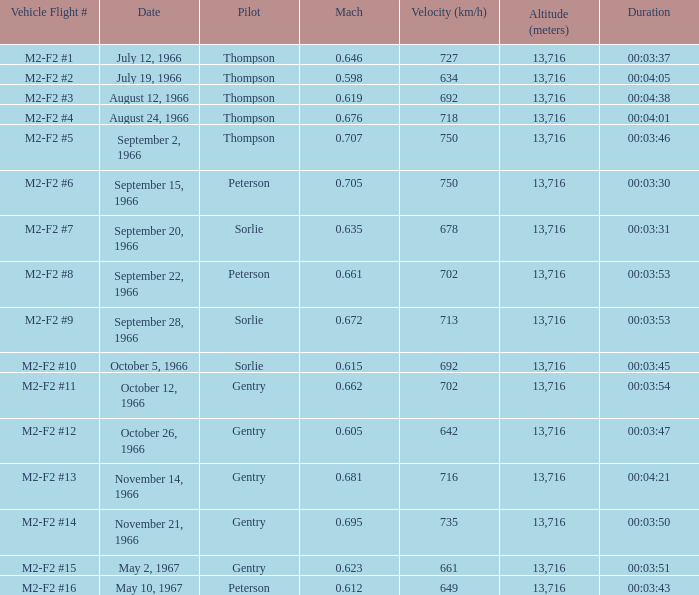662? October 12, 1966. 